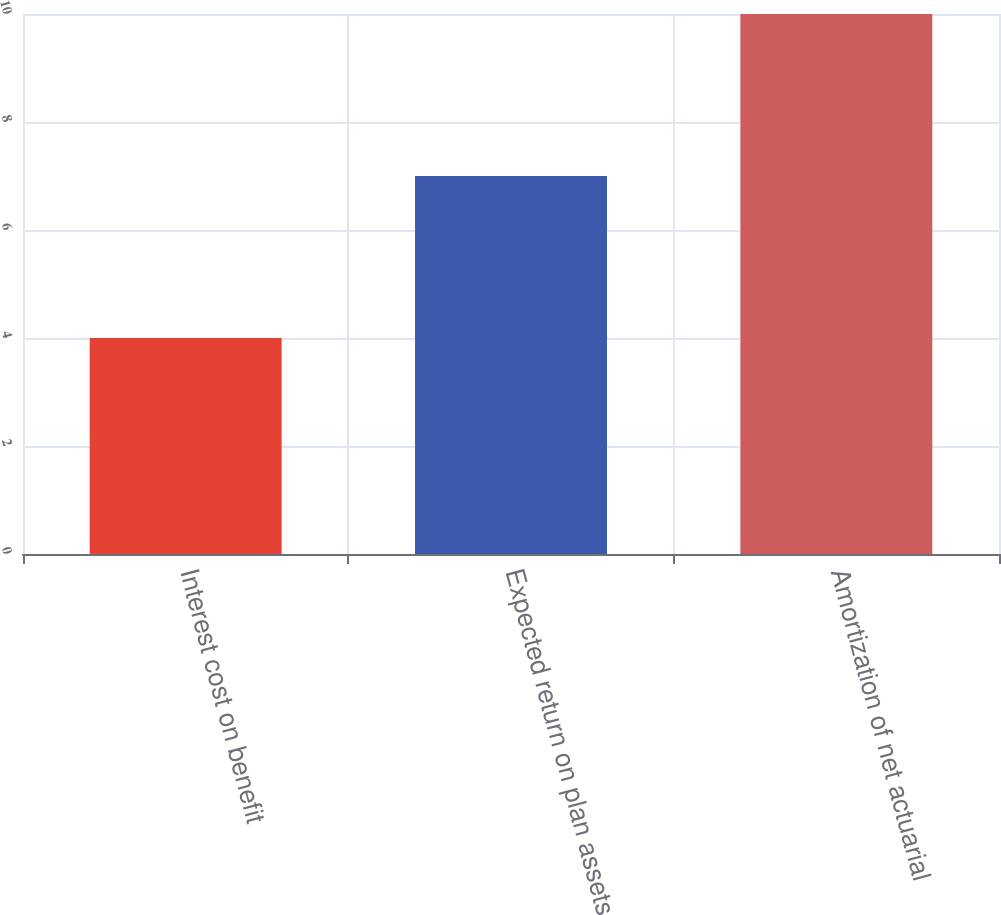Convert chart. <chart><loc_0><loc_0><loc_500><loc_500><bar_chart><fcel>Interest cost on benefit<fcel>Expected return on plan assets<fcel>Amortization of net actuarial<nl><fcel>4<fcel>7<fcel>10<nl></chart> 